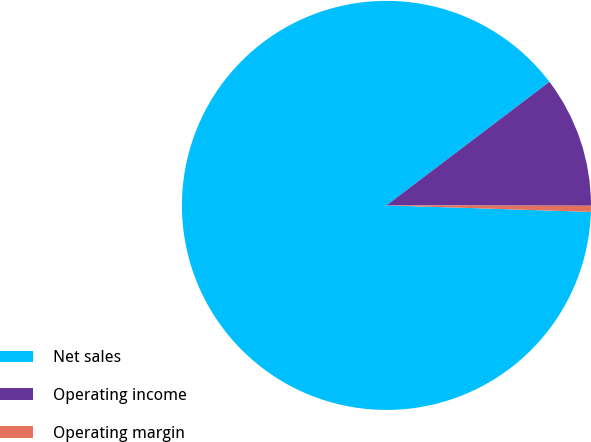Convert chart. <chart><loc_0><loc_0><loc_500><loc_500><pie_chart><fcel>Net sales<fcel>Operating income<fcel>Operating margin<nl><fcel>89.17%<fcel>10.35%<fcel>0.48%<nl></chart> 